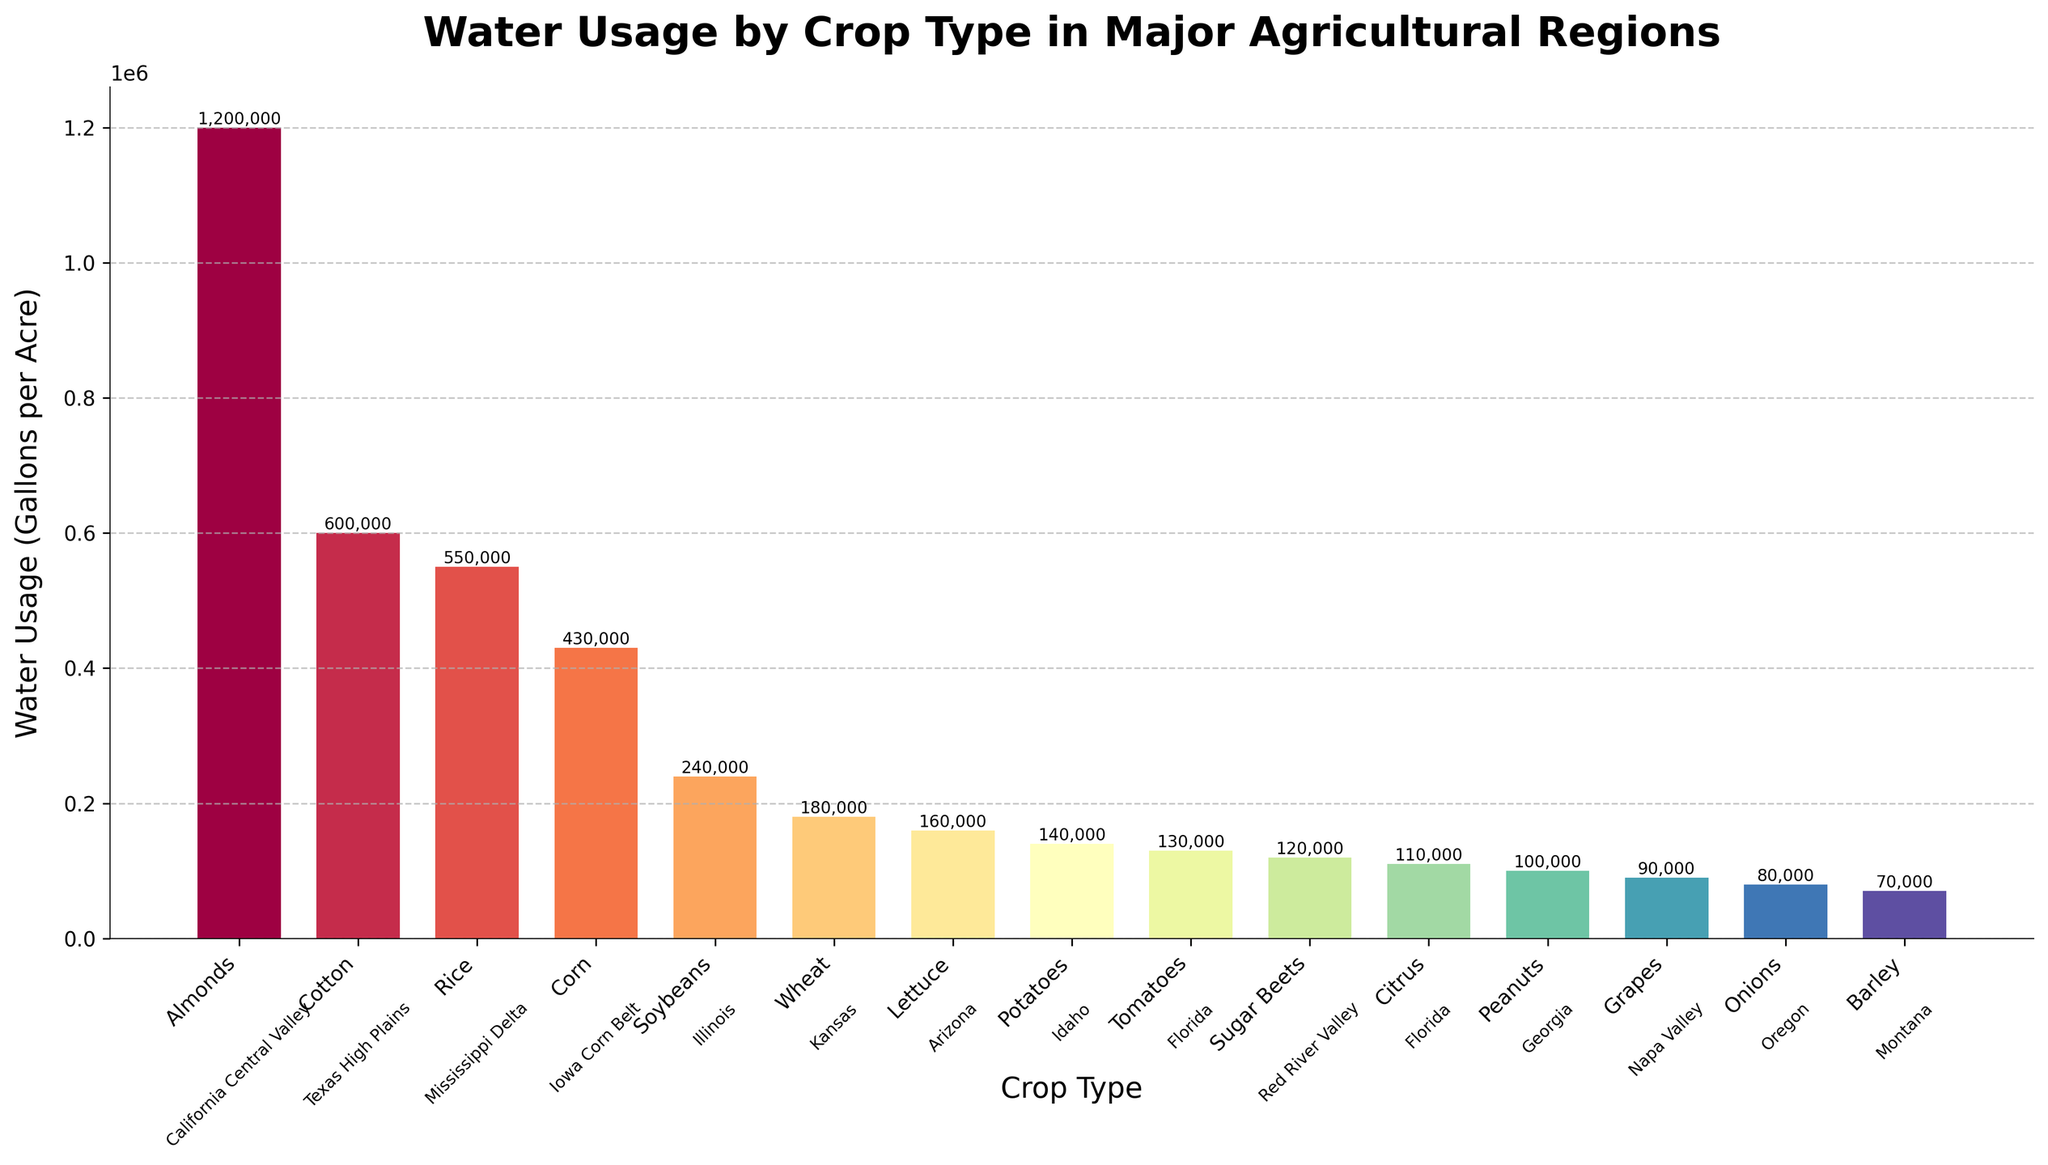How much more water do almonds use compared to corn per acre? To determine this, look at the water usage for almonds (1,200,000 gallons per acre) and for corn (430,000 gallons per acre). Subtract the water usage of corn from almonds: 1,200,000 - 430,000 = 770,000 gallons per acre.
Answer: 770,000 gallons per acre Which crop has the lowest water usage per acre and what is the value? Identify the crop with the smallest value on the y-axis of the bar chart. Onions have the lowest water usage at 80,000 gallons per acre.
Answer: Onions, 80,000 gallons per acre Which two crops have a combined water usage of less than 300,000 gallons per acre? To find the combination, look for two crops whose individual water usage values add up to less than 300,000. For example, onions (80,000 gallons per acre) and barley (70,000 gallons per acre) together use 150,000 gallons per acre, which is less than 300,000.
Answer: Onions and barley Which region is associated with the highest water usage crop, and what is the water usage? The highest water usage crop is almonds with 1,200,000 gallons per acre. From the annotations, almonds are grown in the California Central Valley.
Answer: California Central Valley, 1,200,000 gallons per acre How does the water usage of wheat compare to that of potatoes? Observe the bars for both crops. Wheat has a water usage of 180,000 gallons per acre, while potatoes have 140,000 gallons per acre. Subtract the lower value from the higher one: 180,000 - 140,000 = 40,000 gallons per acre more for wheat.
Answer: Wheat uses 40,000 gallons per acre more What is the average water usage per acre across all the crops? To find this, sum all the water usage values and divide by the number of crops. The sum is 1200000 + 600000 + 550000 + 430000 + 240000 + 180000 + 160000 + 140000 + 130000 + 120000 + 110000 + 100000 + 90000 + 80000 + 70000 = 4,870,000 gallons. Divide by 15 crops: 4,870,000 / 15 ≈ 324,667 gallons per acre.
Answer: Approximately 324,667 gallons per acre Which crop in Florida has the higher water usage per acre, citrus or tomatoes? By looking at the bar heights, citrus uses 110,000 gallons per acre and tomatoes use 130,000 gallons per acre. Therefore, tomatoes use more water.
Answer: Tomatoes What is the difference in water usage between the crop with the highest water usage and the one with the lowest? Almonds have the highest water usage at 1,200,000 gallons per acre, and onions have the lowest at 80,000 gallons per acre. Subtract the smallest from the largest: 1,200,000 - 80,000 = 1,120,000 gallons per acre.
Answer: 1,120,000 gallons per acre Rank the top three crops based on water usage. Find the three tallest bars on the chart. They belong to almonds (1,200,000 gallons per acre), cotton (600,000 gallons per acre), and rice (550,000 gallons per acre).
Answer: Almonds, cotton, rice 